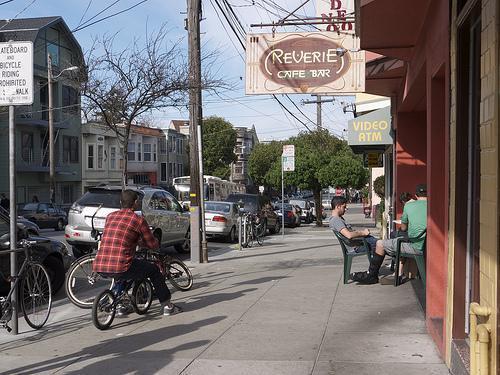How many people are there?
Give a very brief answer. 4. 